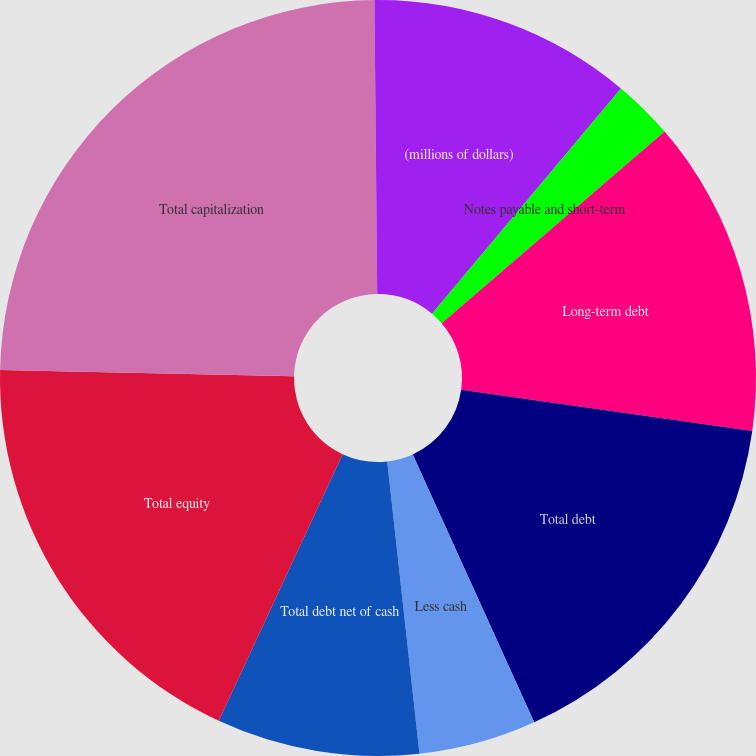Convert chart. <chart><loc_0><loc_0><loc_500><loc_500><pie_chart><fcel>(millions of dollars)<fcel>Notes payable and short-term<fcel>Long-term debt<fcel>Total debt<fcel>Less cash<fcel>Total debt net of cash<fcel>Total equity<fcel>Total capitalization<fcel>Total debt net of cash to<nl><fcel>11.11%<fcel>2.59%<fcel>13.54%<fcel>15.98%<fcel>5.03%<fcel>8.67%<fcel>18.42%<fcel>24.51%<fcel>0.15%<nl></chart> 